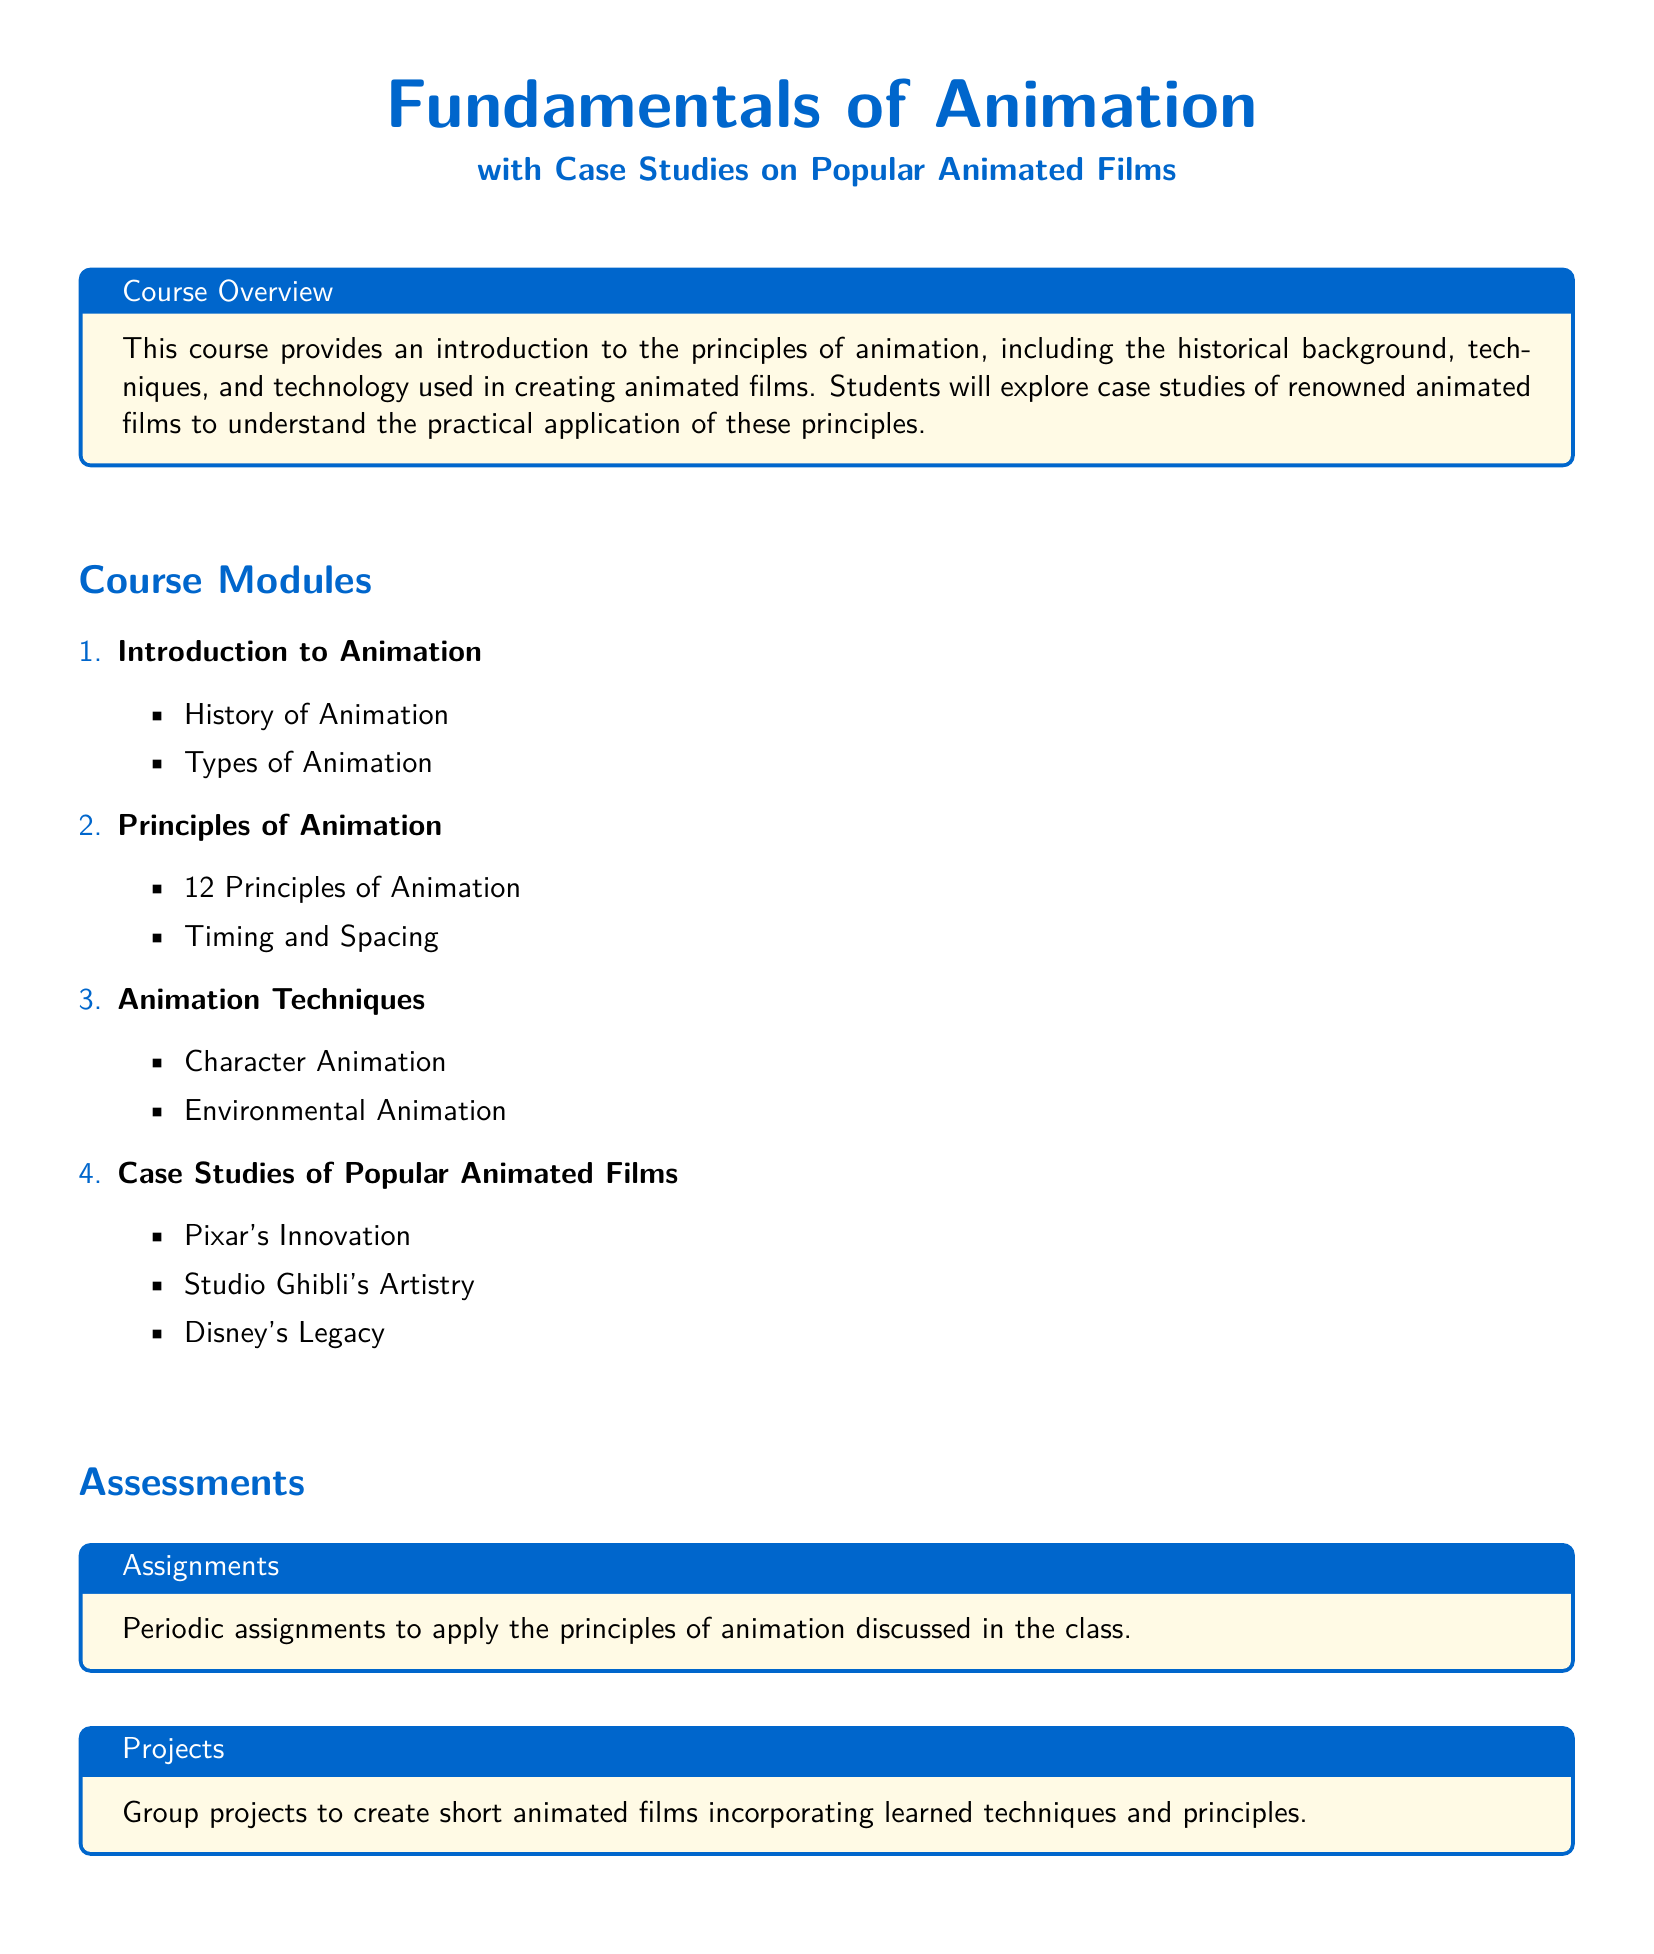what is the title of the syllabus? The title of the syllabus is the main subject covered in the document, which is "Fundamentals of Animation."
Answer: Fundamentals of Animation how many principles of animation are there? The number mentioned in the syllabus indicates the total number of principles of animation, which is specified under "Principles of Animation."
Answer: 12 what technology is discussed in this course? The syllabus mentions that the course covers the "technology used in creating animated films," which reflects the tools and methods utilized in animation.
Answer: Technology name one case study of an animated film. The course includes case studies of well-known animated films, and one of them is specifically mentioned in a list that highlights its importance.
Answer: Pixar's Innovation what is included in the assignments section? The "Assignments" section describes what students will do to practice the concepts learned in class related to animation.
Answer: Periodic assignments what type of projects will students create? The projects described in the syllabus focus on a collaborative effort among students to produce specific creative content utilizing the skills acquired throughout the course.
Answer: Short animated films which studio is associated with artistry in the case studies? The syllabus lists notable animated film studios alongside their attributes, one of which is particularly known for its artistic contributions in animation.
Answer: Studio Ghibli's Artistry what color is used for the main headings? The color specified in the syllabus for the main headings provides a visual identity for better readability, enhancing the presentation of the document.
Answer: Blue 